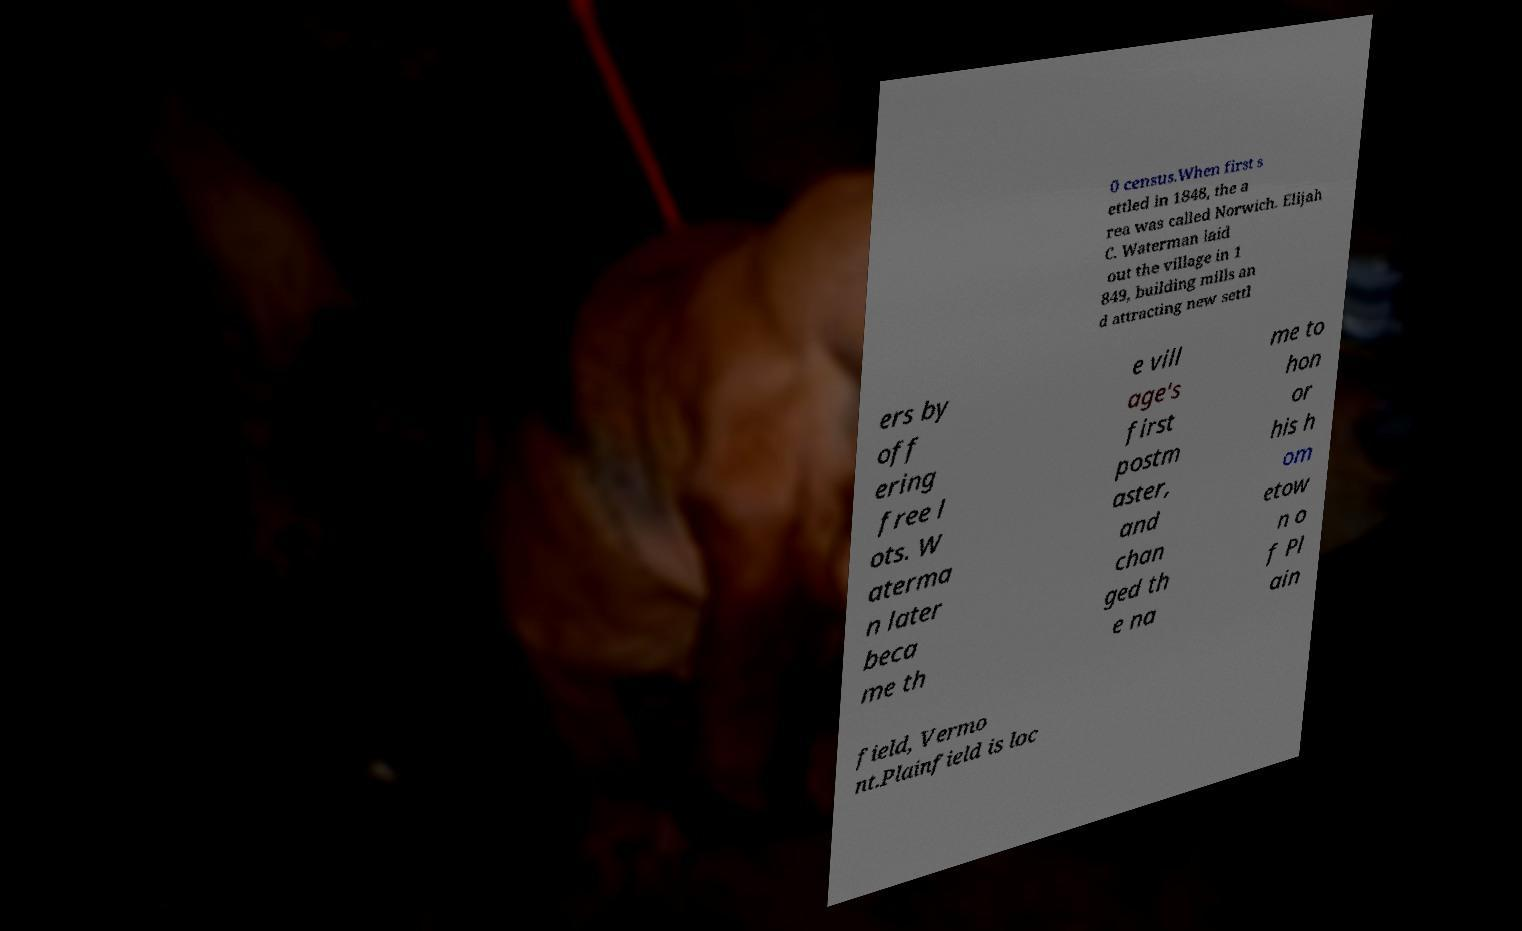I need the written content from this picture converted into text. Can you do that? 0 census.When first s ettled in 1848, the a rea was called Norwich. Elijah C. Waterman laid out the village in 1 849, building mills an d attracting new settl ers by off ering free l ots. W aterma n later beca me th e vill age's first postm aster, and chan ged th e na me to hon or his h om etow n o f Pl ain field, Vermo nt.Plainfield is loc 